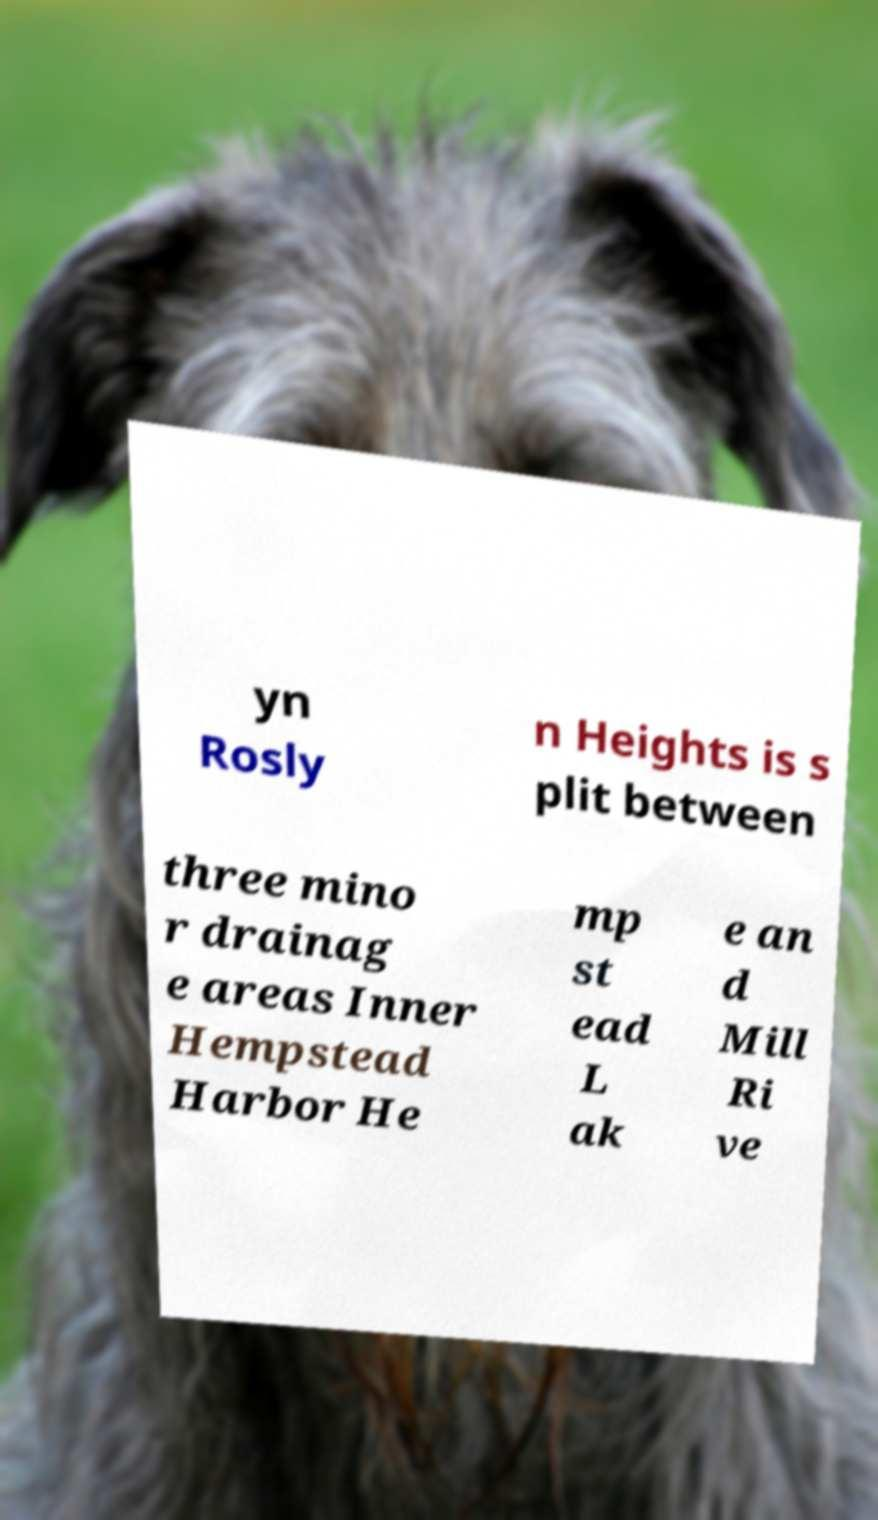Could you extract and type out the text from this image? yn Rosly n Heights is s plit between three mino r drainag e areas Inner Hempstead Harbor He mp st ead L ak e an d Mill Ri ve 